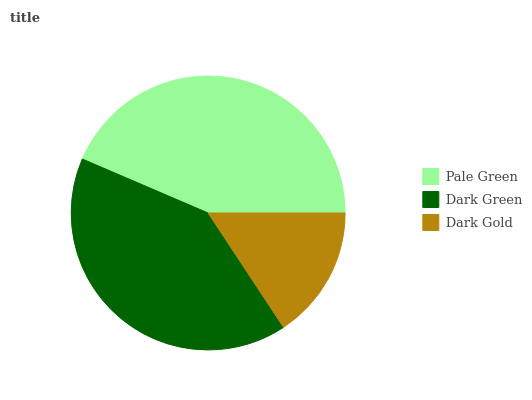Is Dark Gold the minimum?
Answer yes or no. Yes. Is Pale Green the maximum?
Answer yes or no. Yes. Is Dark Green the minimum?
Answer yes or no. No. Is Dark Green the maximum?
Answer yes or no. No. Is Pale Green greater than Dark Green?
Answer yes or no. Yes. Is Dark Green less than Pale Green?
Answer yes or no. Yes. Is Dark Green greater than Pale Green?
Answer yes or no. No. Is Pale Green less than Dark Green?
Answer yes or no. No. Is Dark Green the high median?
Answer yes or no. Yes. Is Dark Green the low median?
Answer yes or no. Yes. Is Dark Gold the high median?
Answer yes or no. No. Is Dark Gold the low median?
Answer yes or no. No. 